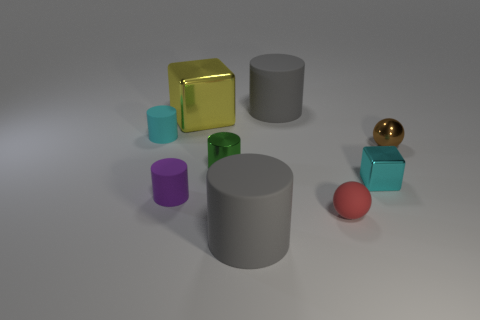Is the purple object the same size as the yellow block?
Provide a succinct answer. No. There is a green metallic thing; is its shape the same as the big gray thing that is in front of the green metallic cylinder?
Offer a very short reply. Yes. There is a large yellow shiny cube; are there any tiny green metal objects behind it?
Your response must be concise. No. How many other big yellow metal things have the same shape as the yellow shiny thing?
Your answer should be very brief. 0. Are the brown thing and the large gray cylinder that is behind the tiny red rubber thing made of the same material?
Provide a short and direct response. No. What number of small gray matte blocks are there?
Provide a short and direct response. 0. There is a metallic block on the right side of the red rubber sphere; what size is it?
Ensure brevity in your answer.  Small. What number of green cylinders are the same size as the cyan metallic thing?
Your response must be concise. 1. There is a thing that is on the left side of the tiny red rubber ball and in front of the small purple rubber cylinder; what material is it?
Your response must be concise. Rubber. There is a purple object that is the same size as the metallic cylinder; what is its material?
Keep it short and to the point. Rubber. 